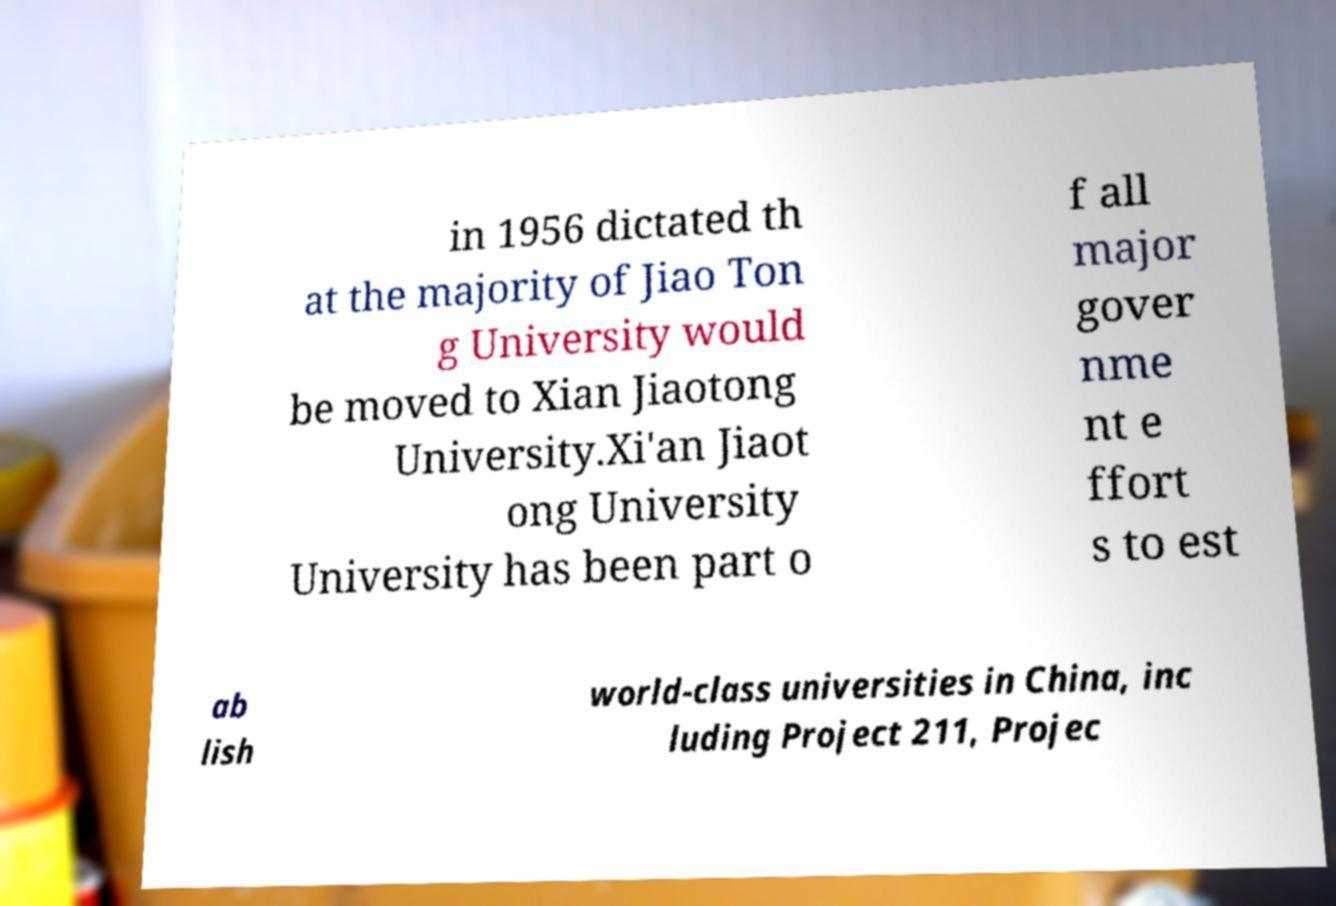I need the written content from this picture converted into text. Can you do that? in 1956 dictated th at the majority of Jiao Ton g University would be moved to Xian Jiaotong University.Xi'an Jiaot ong University University has been part o f all major gover nme nt e ffort s to est ab lish world-class universities in China, inc luding Project 211, Projec 